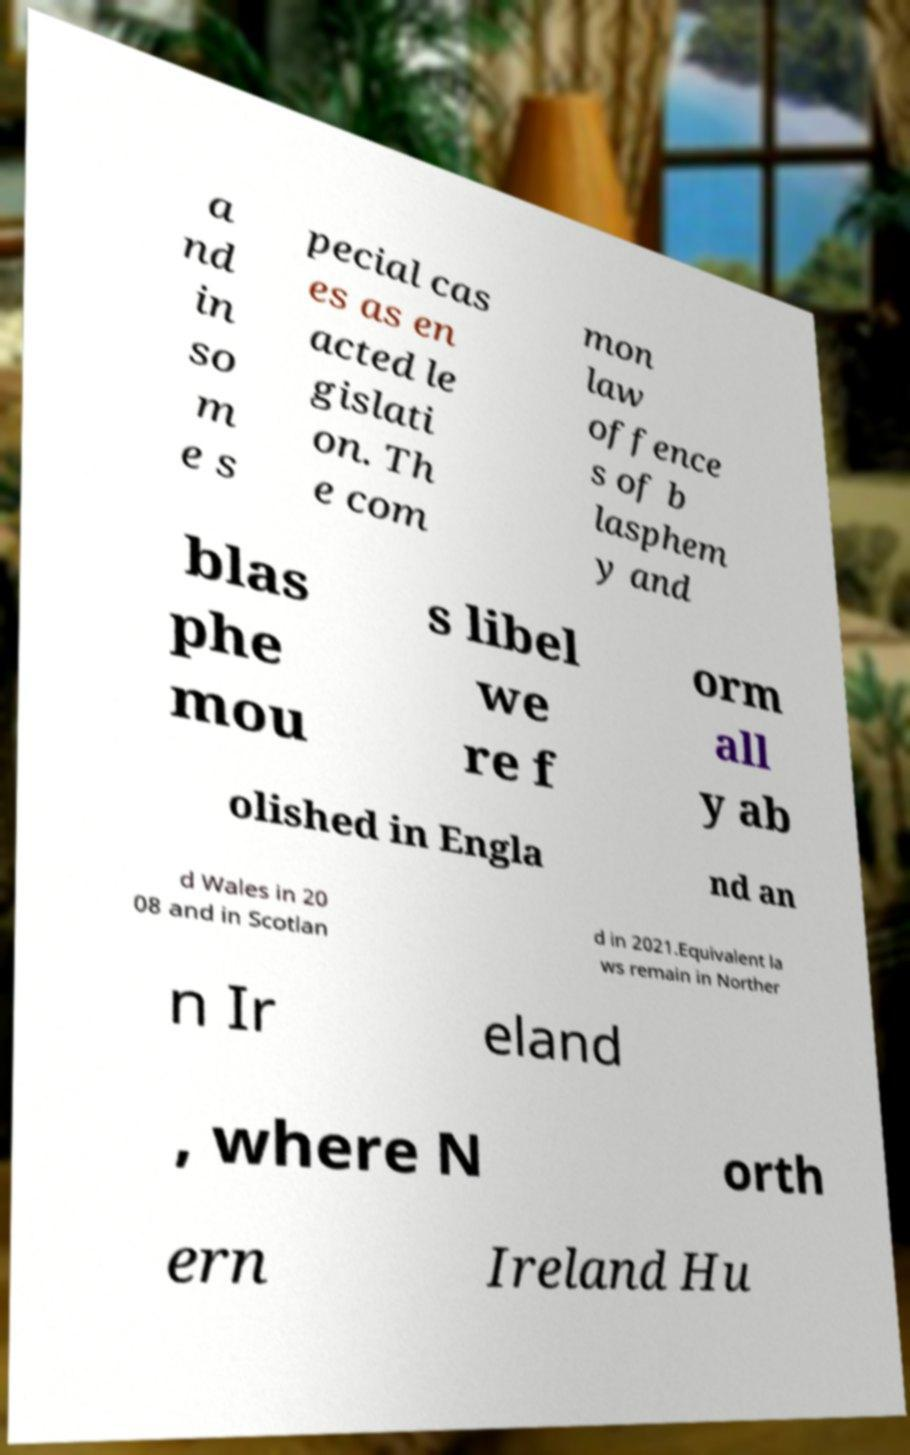What messages or text are displayed in this image? I need them in a readable, typed format. a nd in so m e s pecial cas es as en acted le gislati on. Th e com mon law offence s of b lasphem y and blas phe mou s libel we re f orm all y ab olished in Engla nd an d Wales in 20 08 and in Scotlan d in 2021.Equivalent la ws remain in Norther n Ir eland , where N orth ern Ireland Hu 